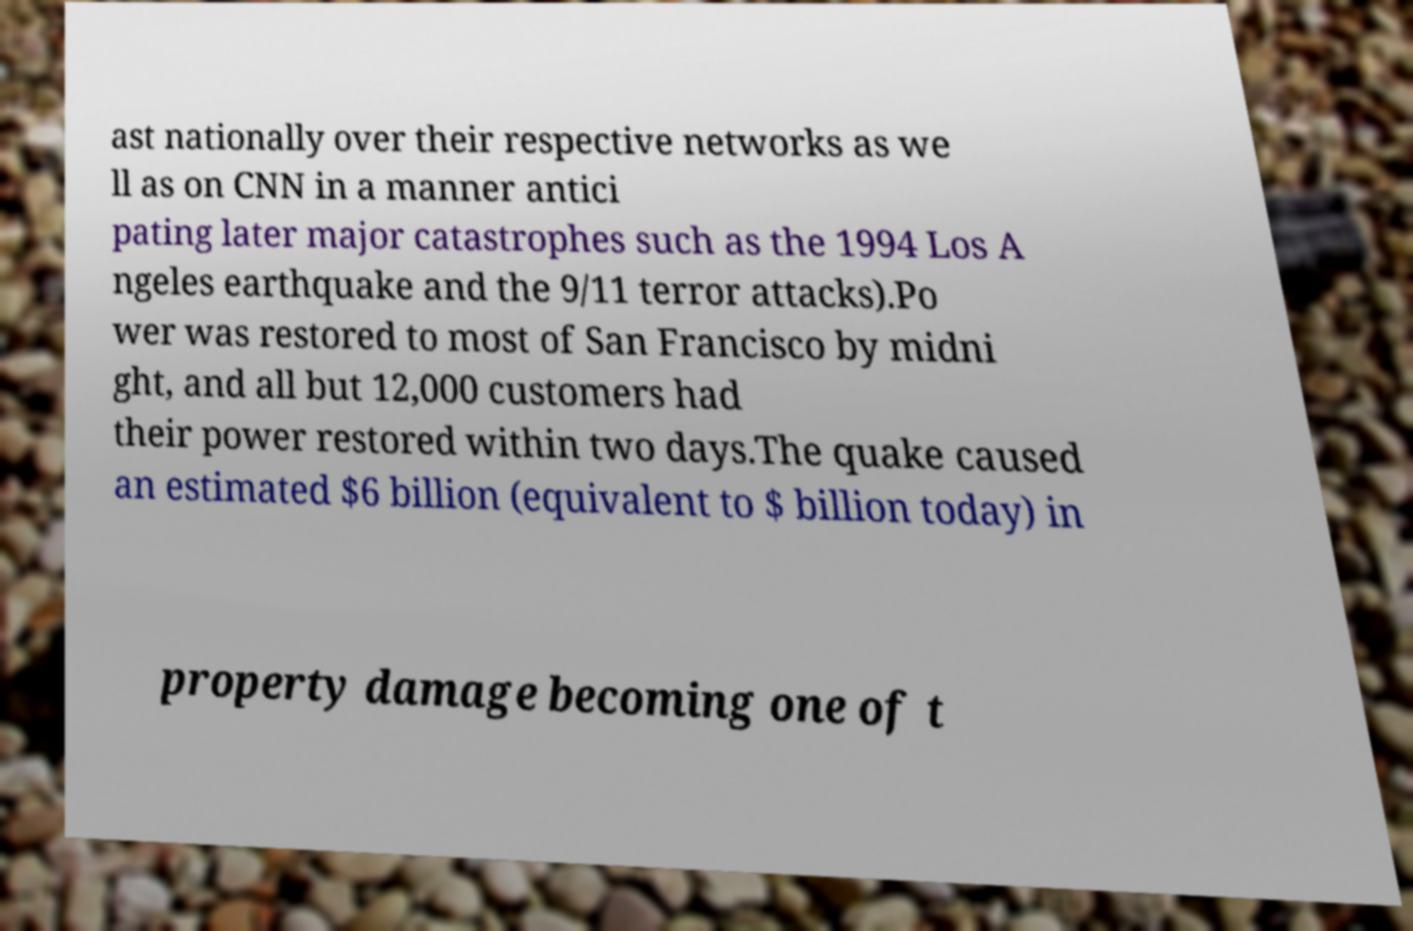Could you assist in decoding the text presented in this image and type it out clearly? ast nationally over their respective networks as we ll as on CNN in a manner antici pating later major catastrophes such as the 1994 Los A ngeles earthquake and the 9/11 terror attacks).Po wer was restored to most of San Francisco by midni ght, and all but 12,000 customers had their power restored within two days.The quake caused an estimated $6 billion (equivalent to $ billion today) in property damage becoming one of t 